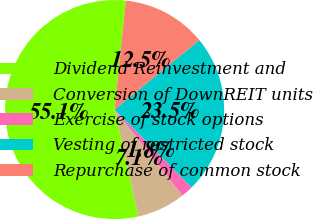<chart> <loc_0><loc_0><loc_500><loc_500><pie_chart><fcel>Dividend Reinvestment and<fcel>Conversion of DownREIT units<fcel>Exercise of stock options<fcel>Vesting of restricted stock<fcel>Repurchase of common stock<nl><fcel>55.12%<fcel>7.13%<fcel>1.79%<fcel>23.5%<fcel>12.46%<nl></chart> 